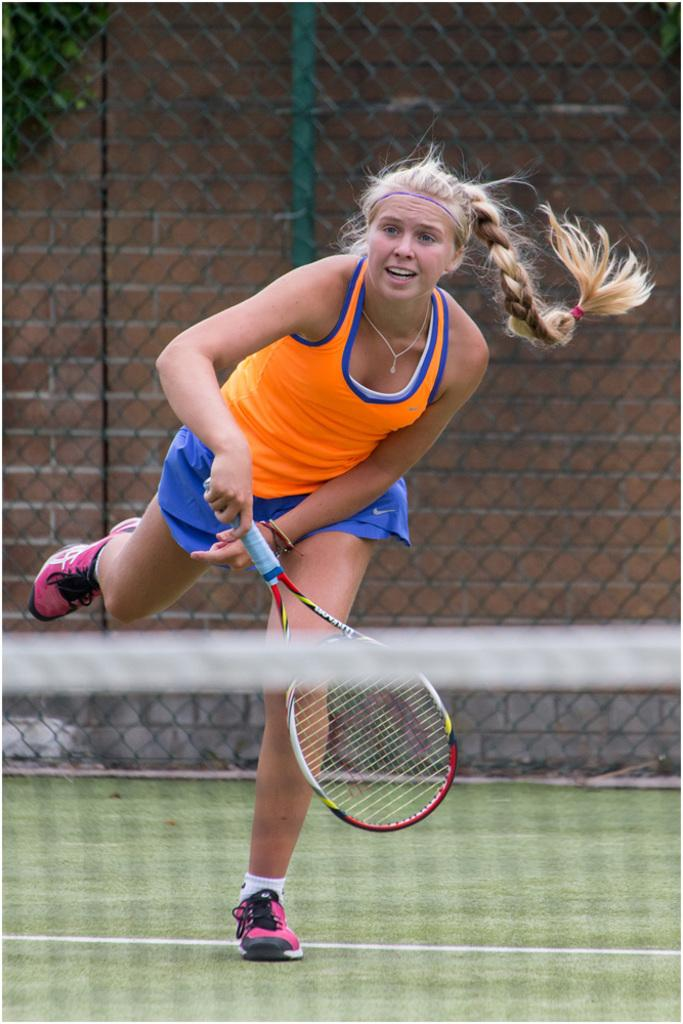What activity is the woman in the image engaged in? The woman is playing tennis in the image. What is the woman holding while playing tennis? The woman is holding a tennis racket. What can be seen in the background of the image? There is fencing and a wall with bricks in the background of the image. Are there any plants visible in the image? Yes, there are plants placed near the wall in the background of the image. What type of bucket is the woman using to rub the wall in the image? There is no bucket or rubbing activity present in the image; the woman is playing tennis and there is no mention of a wall being rubbed. 